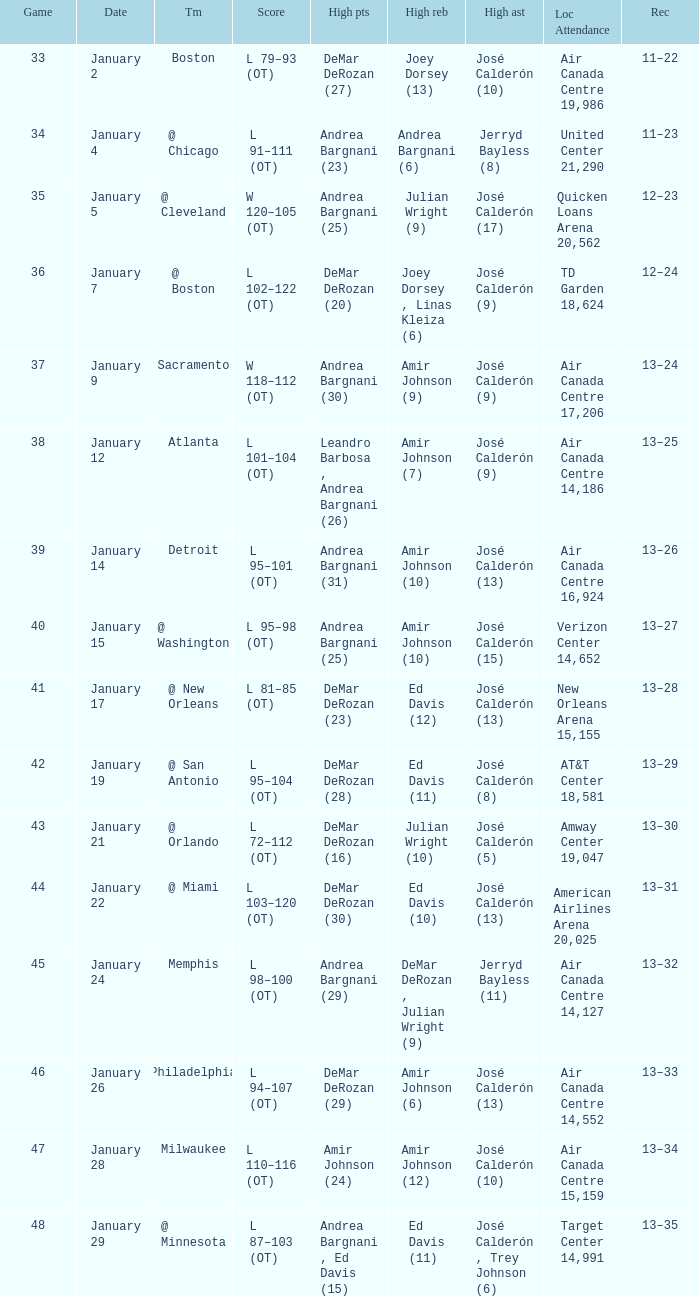Could you parse the entire table? {'header': ['Game', 'Date', 'Tm', 'Score', 'High pts', 'High reb', 'High ast', 'Loc Attendance', 'Rec'], 'rows': [['33', 'January 2', 'Boston', 'L 79–93 (OT)', 'DeMar DeRozan (27)', 'Joey Dorsey (13)', 'José Calderón (10)', 'Air Canada Centre 19,986', '11–22'], ['34', 'January 4', '@ Chicago', 'L 91–111 (OT)', 'Andrea Bargnani (23)', 'Andrea Bargnani (6)', 'Jerryd Bayless (8)', 'United Center 21,290', '11–23'], ['35', 'January 5', '@ Cleveland', 'W 120–105 (OT)', 'Andrea Bargnani (25)', 'Julian Wright (9)', 'José Calderón (17)', 'Quicken Loans Arena 20,562', '12–23'], ['36', 'January 7', '@ Boston', 'L 102–122 (OT)', 'DeMar DeRozan (20)', 'Joey Dorsey , Linas Kleiza (6)', 'José Calderón (9)', 'TD Garden 18,624', '12–24'], ['37', 'January 9', 'Sacramento', 'W 118–112 (OT)', 'Andrea Bargnani (30)', 'Amir Johnson (9)', 'José Calderón (9)', 'Air Canada Centre 17,206', '13–24'], ['38', 'January 12', 'Atlanta', 'L 101–104 (OT)', 'Leandro Barbosa , Andrea Bargnani (26)', 'Amir Johnson (7)', 'José Calderón (9)', 'Air Canada Centre 14,186', '13–25'], ['39', 'January 14', 'Detroit', 'L 95–101 (OT)', 'Andrea Bargnani (31)', 'Amir Johnson (10)', 'José Calderón (13)', 'Air Canada Centre 16,924', '13–26'], ['40', 'January 15', '@ Washington', 'L 95–98 (OT)', 'Andrea Bargnani (25)', 'Amir Johnson (10)', 'José Calderón (15)', 'Verizon Center 14,652', '13–27'], ['41', 'January 17', '@ New Orleans', 'L 81–85 (OT)', 'DeMar DeRozan (23)', 'Ed Davis (12)', 'José Calderón (13)', 'New Orleans Arena 15,155', '13–28'], ['42', 'January 19', '@ San Antonio', 'L 95–104 (OT)', 'DeMar DeRozan (28)', 'Ed Davis (11)', 'José Calderón (8)', 'AT&T Center 18,581', '13–29'], ['43', 'January 21', '@ Orlando', 'L 72–112 (OT)', 'DeMar DeRozan (16)', 'Julian Wright (10)', 'José Calderón (5)', 'Amway Center 19,047', '13–30'], ['44', 'January 22', '@ Miami', 'L 103–120 (OT)', 'DeMar DeRozan (30)', 'Ed Davis (10)', 'José Calderón (13)', 'American Airlines Arena 20,025', '13–31'], ['45', 'January 24', 'Memphis', 'L 98–100 (OT)', 'Andrea Bargnani (29)', 'DeMar DeRozan , Julian Wright (9)', 'Jerryd Bayless (11)', 'Air Canada Centre 14,127', '13–32'], ['46', 'January 26', 'Philadelphia', 'L 94–107 (OT)', 'DeMar DeRozan (29)', 'Amir Johnson (6)', 'José Calderón (13)', 'Air Canada Centre 14,552', '13–33'], ['47', 'January 28', 'Milwaukee', 'L 110–116 (OT)', 'Amir Johnson (24)', 'Amir Johnson (12)', 'José Calderón (10)', 'Air Canada Centre 15,159', '13–34'], ['48', 'January 29', '@ Minnesota', 'L 87–103 (OT)', 'Andrea Bargnani , Ed Davis (15)', 'Ed Davis (11)', 'José Calderón , Trey Johnson (6)', 'Target Center 14,991', '13–35']]} Name the number of high rebounds for january 5 1.0. 